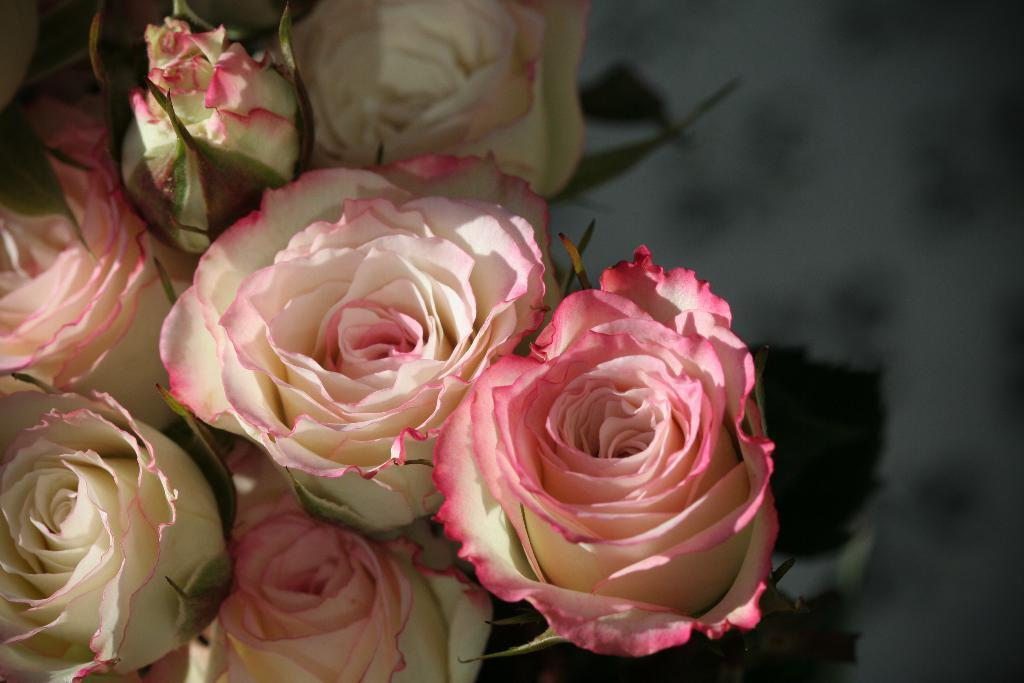What type of flowers are in the image? There is a bunch of rose flowers in the image. What colors can be seen in the rose flowers? The rose flowers are white and pink in color. What type of cake is decorated with a shoe-shaped badge in the image? There is no cake, shoe, or badge present in the image; it only features a bunch of rose flowers. 